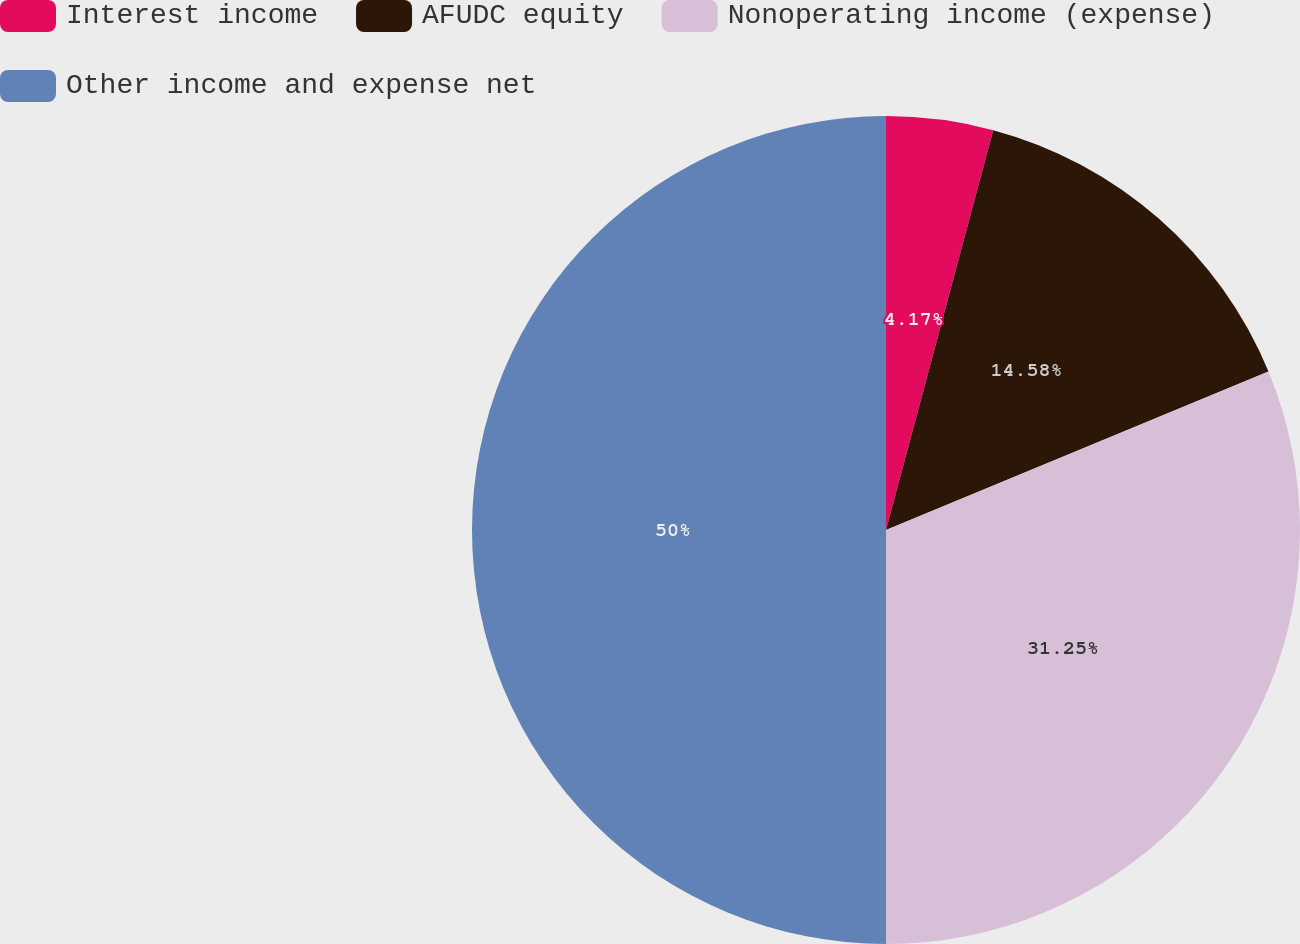Convert chart. <chart><loc_0><loc_0><loc_500><loc_500><pie_chart><fcel>Interest income<fcel>AFUDC equity<fcel>Nonoperating income (expense)<fcel>Other income and expense net<nl><fcel>4.17%<fcel>14.58%<fcel>31.25%<fcel>50.0%<nl></chart> 